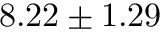<formula> <loc_0><loc_0><loc_500><loc_500>8 . 2 2 \pm 1 . 2 9</formula> 